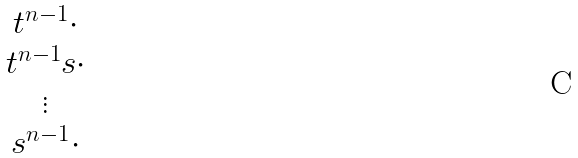<formula> <loc_0><loc_0><loc_500><loc_500>\begin{matrix} t ^ { n - 1 } \cdot \\ t ^ { n - 1 } s \cdot \\ \vdots \\ s ^ { n - 1 } \cdot \end{matrix}</formula> 